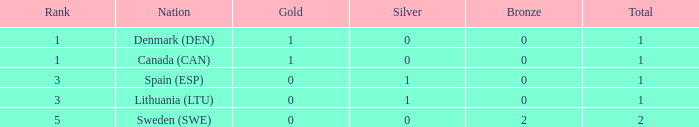What was the placement when there were fewer than 1 gold, no bronze, and more than 1 medal in total? None. 